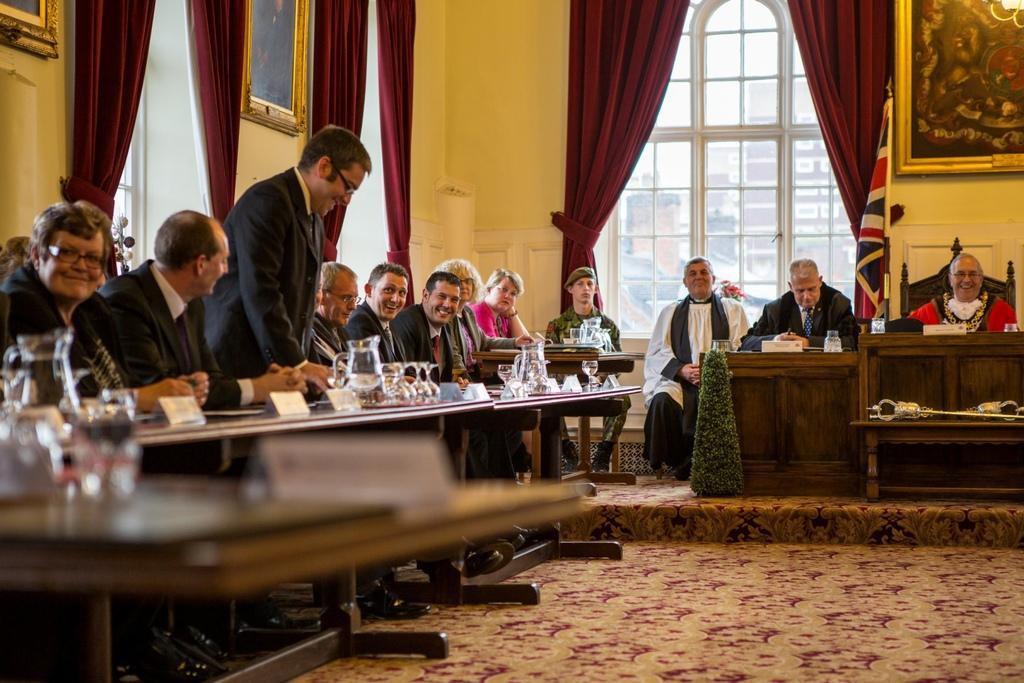Can you describe this image briefly? This is a room in which people are sitting on the chair. On the left a person is standing,he wore spectacles and He is smiling. Beside to him there are few people and they are also smiling. In front of them there is a table on which there is glass of water,jug and glasses. On the right there is a person sitting on the chair and smiling,beside him there is a flag. On the wall we can see frames and there is a window covered with curtain. In front of the table,here there is a plant. 